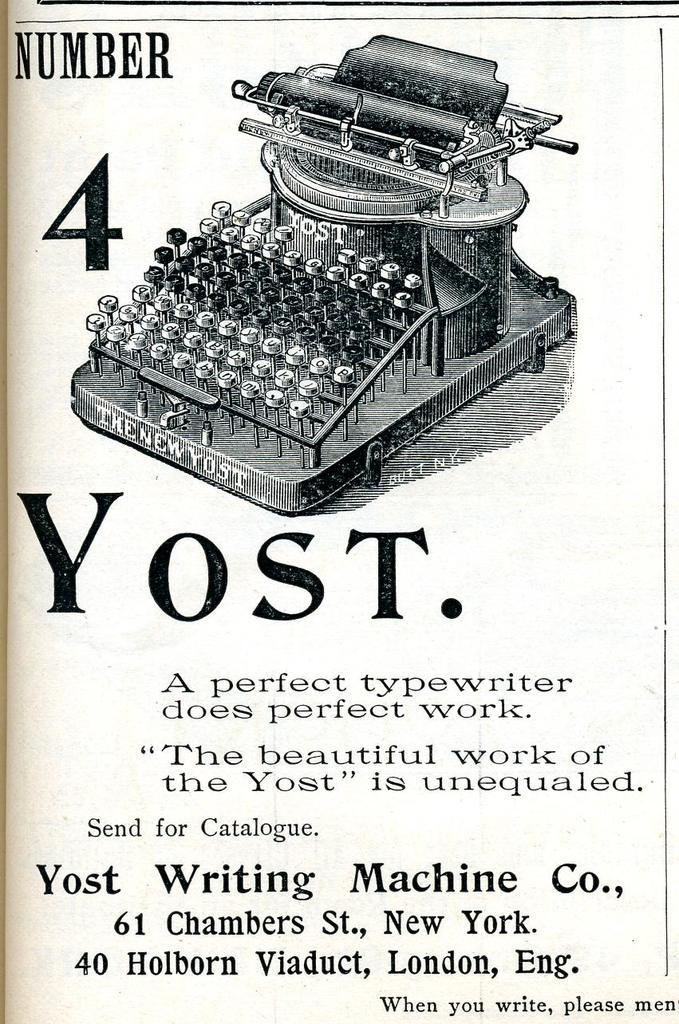<image>
Share a concise interpretation of the image provided. An old page containing information on a Number 4 Yost typewriter. 